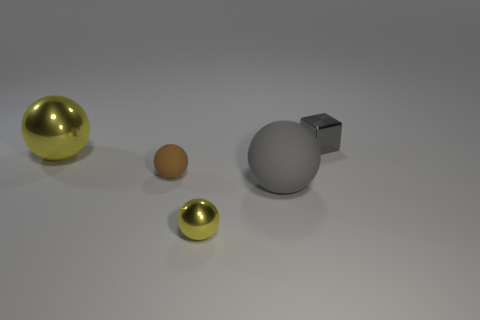Subtract 1 spheres. How many spheres are left? 3 Add 1 large gray matte spheres. How many objects exist? 6 Subtract all cubes. How many objects are left? 4 Subtract all gray matte balls. Subtract all small brown things. How many objects are left? 3 Add 1 brown rubber balls. How many brown rubber balls are left? 2 Add 2 gray rubber balls. How many gray rubber balls exist? 3 Subtract 0 cyan cylinders. How many objects are left? 5 